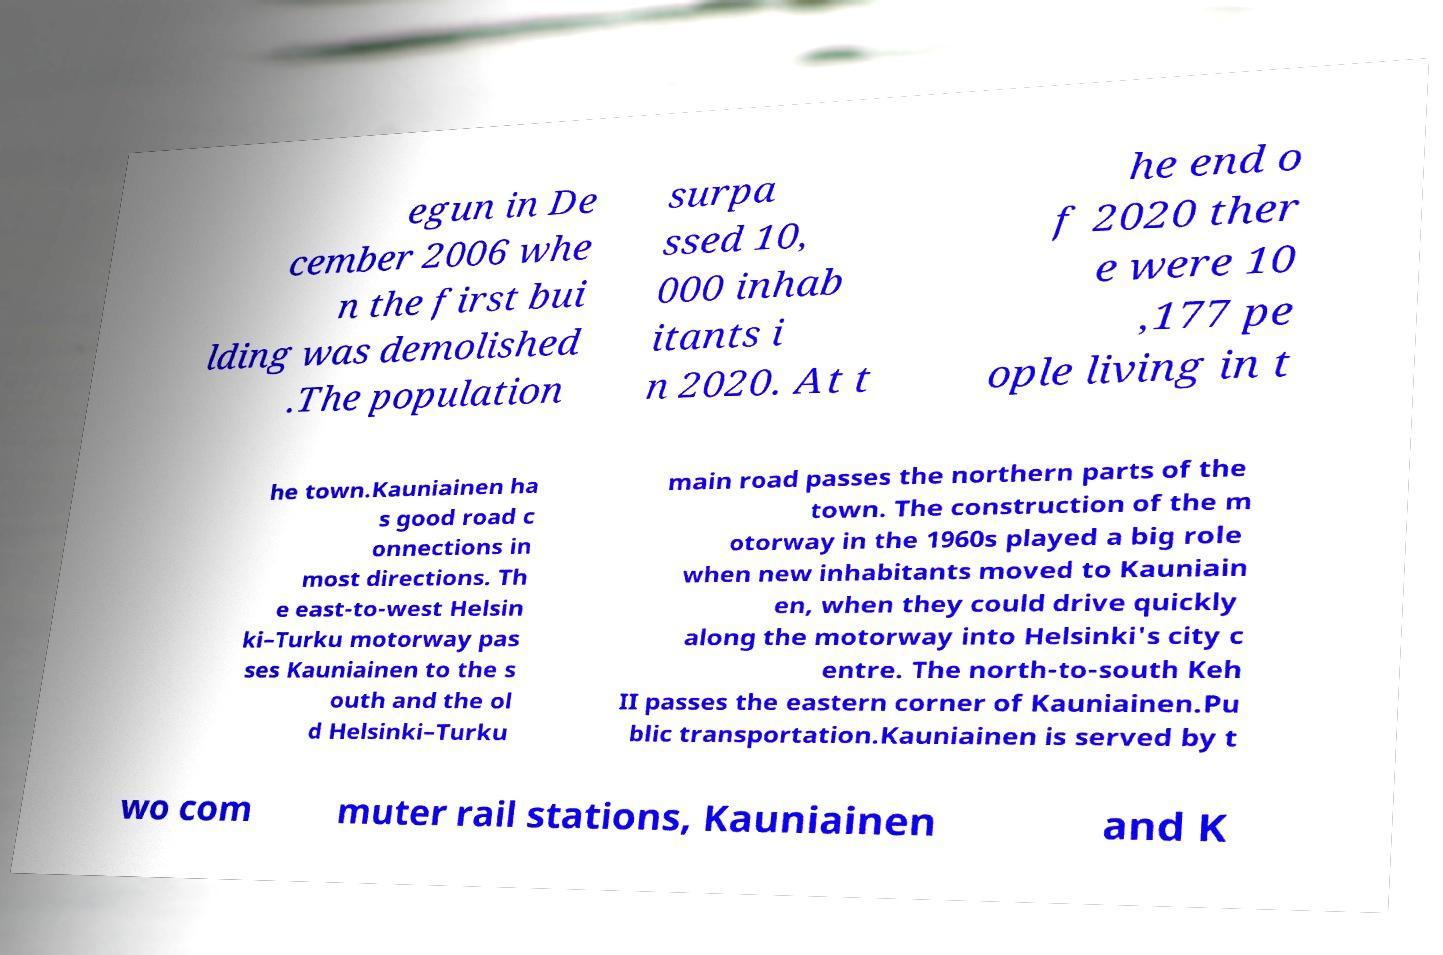Can you accurately transcribe the text from the provided image for me? egun in De cember 2006 whe n the first bui lding was demolished .The population surpa ssed 10, 000 inhab itants i n 2020. At t he end o f 2020 ther e were 10 ,177 pe ople living in t he town.Kauniainen ha s good road c onnections in most directions. Th e east-to-west Helsin ki–Turku motorway pas ses Kauniainen to the s outh and the ol d Helsinki–Turku main road passes the northern parts of the town. The construction of the m otorway in the 1960s played a big role when new inhabitants moved to Kauniain en, when they could drive quickly along the motorway into Helsinki's city c entre. The north-to-south Keh II passes the eastern corner of Kauniainen.Pu blic transportation.Kauniainen is served by t wo com muter rail stations, Kauniainen and K 